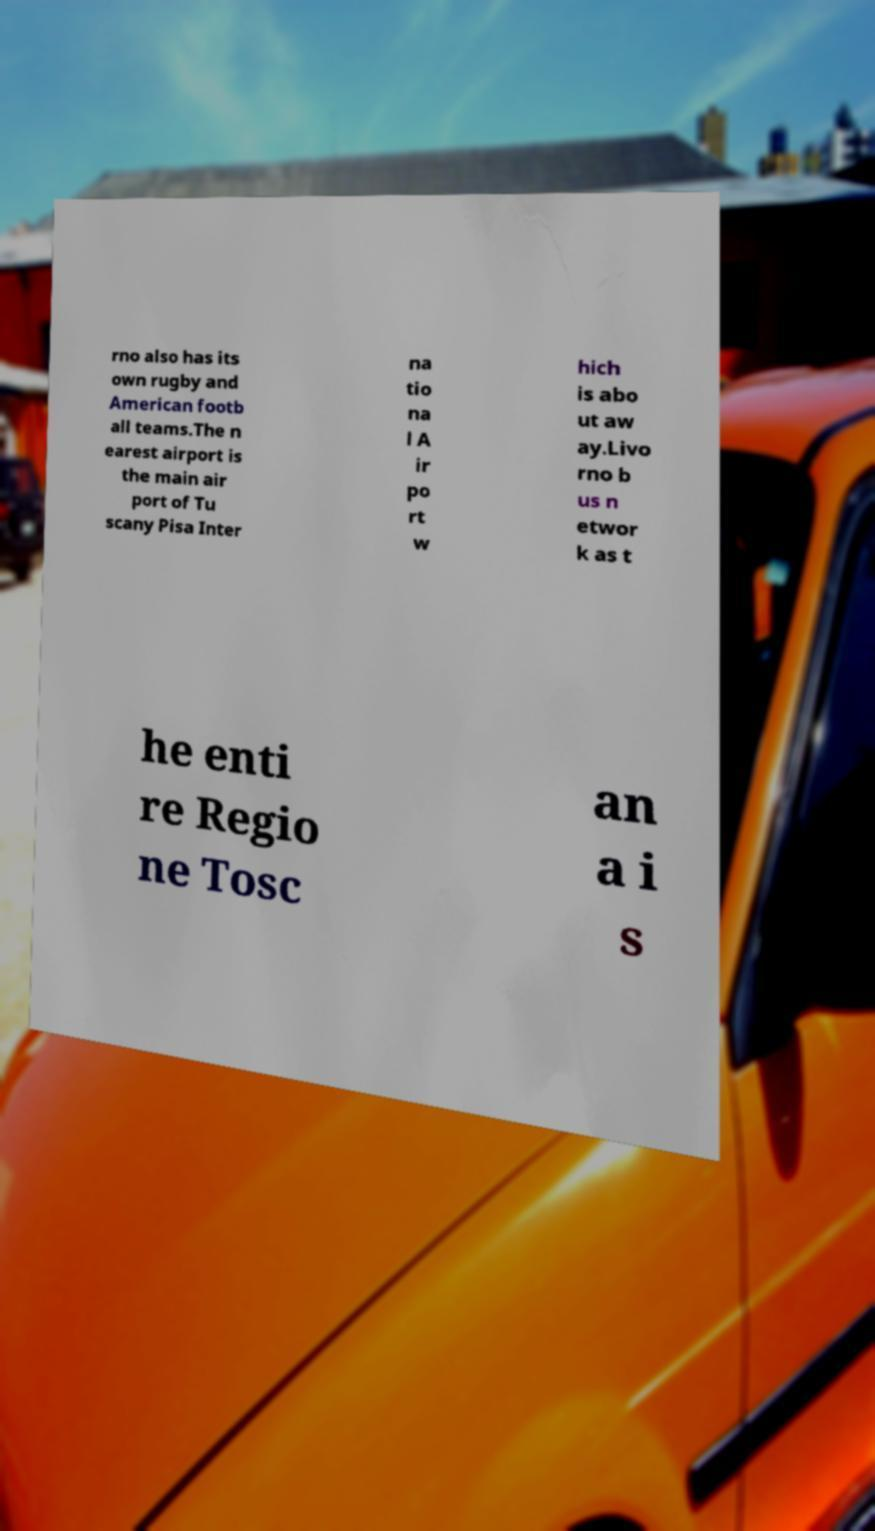Can you accurately transcribe the text from the provided image for me? rno also has its own rugby and American footb all teams.The n earest airport is the main air port of Tu scany Pisa Inter na tio na l A ir po rt w hich is abo ut aw ay.Livo rno b us n etwor k as t he enti re Regio ne Tosc an a i s 